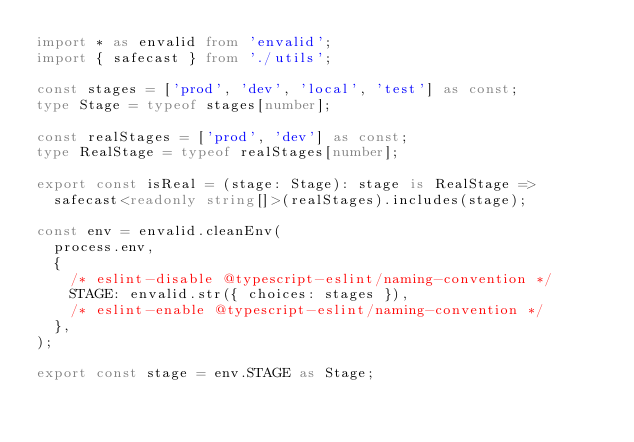Convert code to text. <code><loc_0><loc_0><loc_500><loc_500><_TypeScript_>import * as envalid from 'envalid';
import { safecast } from './utils';

const stages = ['prod', 'dev', 'local', 'test'] as const;
type Stage = typeof stages[number];

const realStages = ['prod', 'dev'] as const;
type RealStage = typeof realStages[number];

export const isReal = (stage: Stage): stage is RealStage =>
  safecast<readonly string[]>(realStages).includes(stage);

const env = envalid.cleanEnv(
  process.env,
  {
    /* eslint-disable @typescript-eslint/naming-convention */
    STAGE: envalid.str({ choices: stages }),
    /* eslint-enable @typescript-eslint/naming-convention */
  },
);

export const stage = env.STAGE as Stage;
</code> 